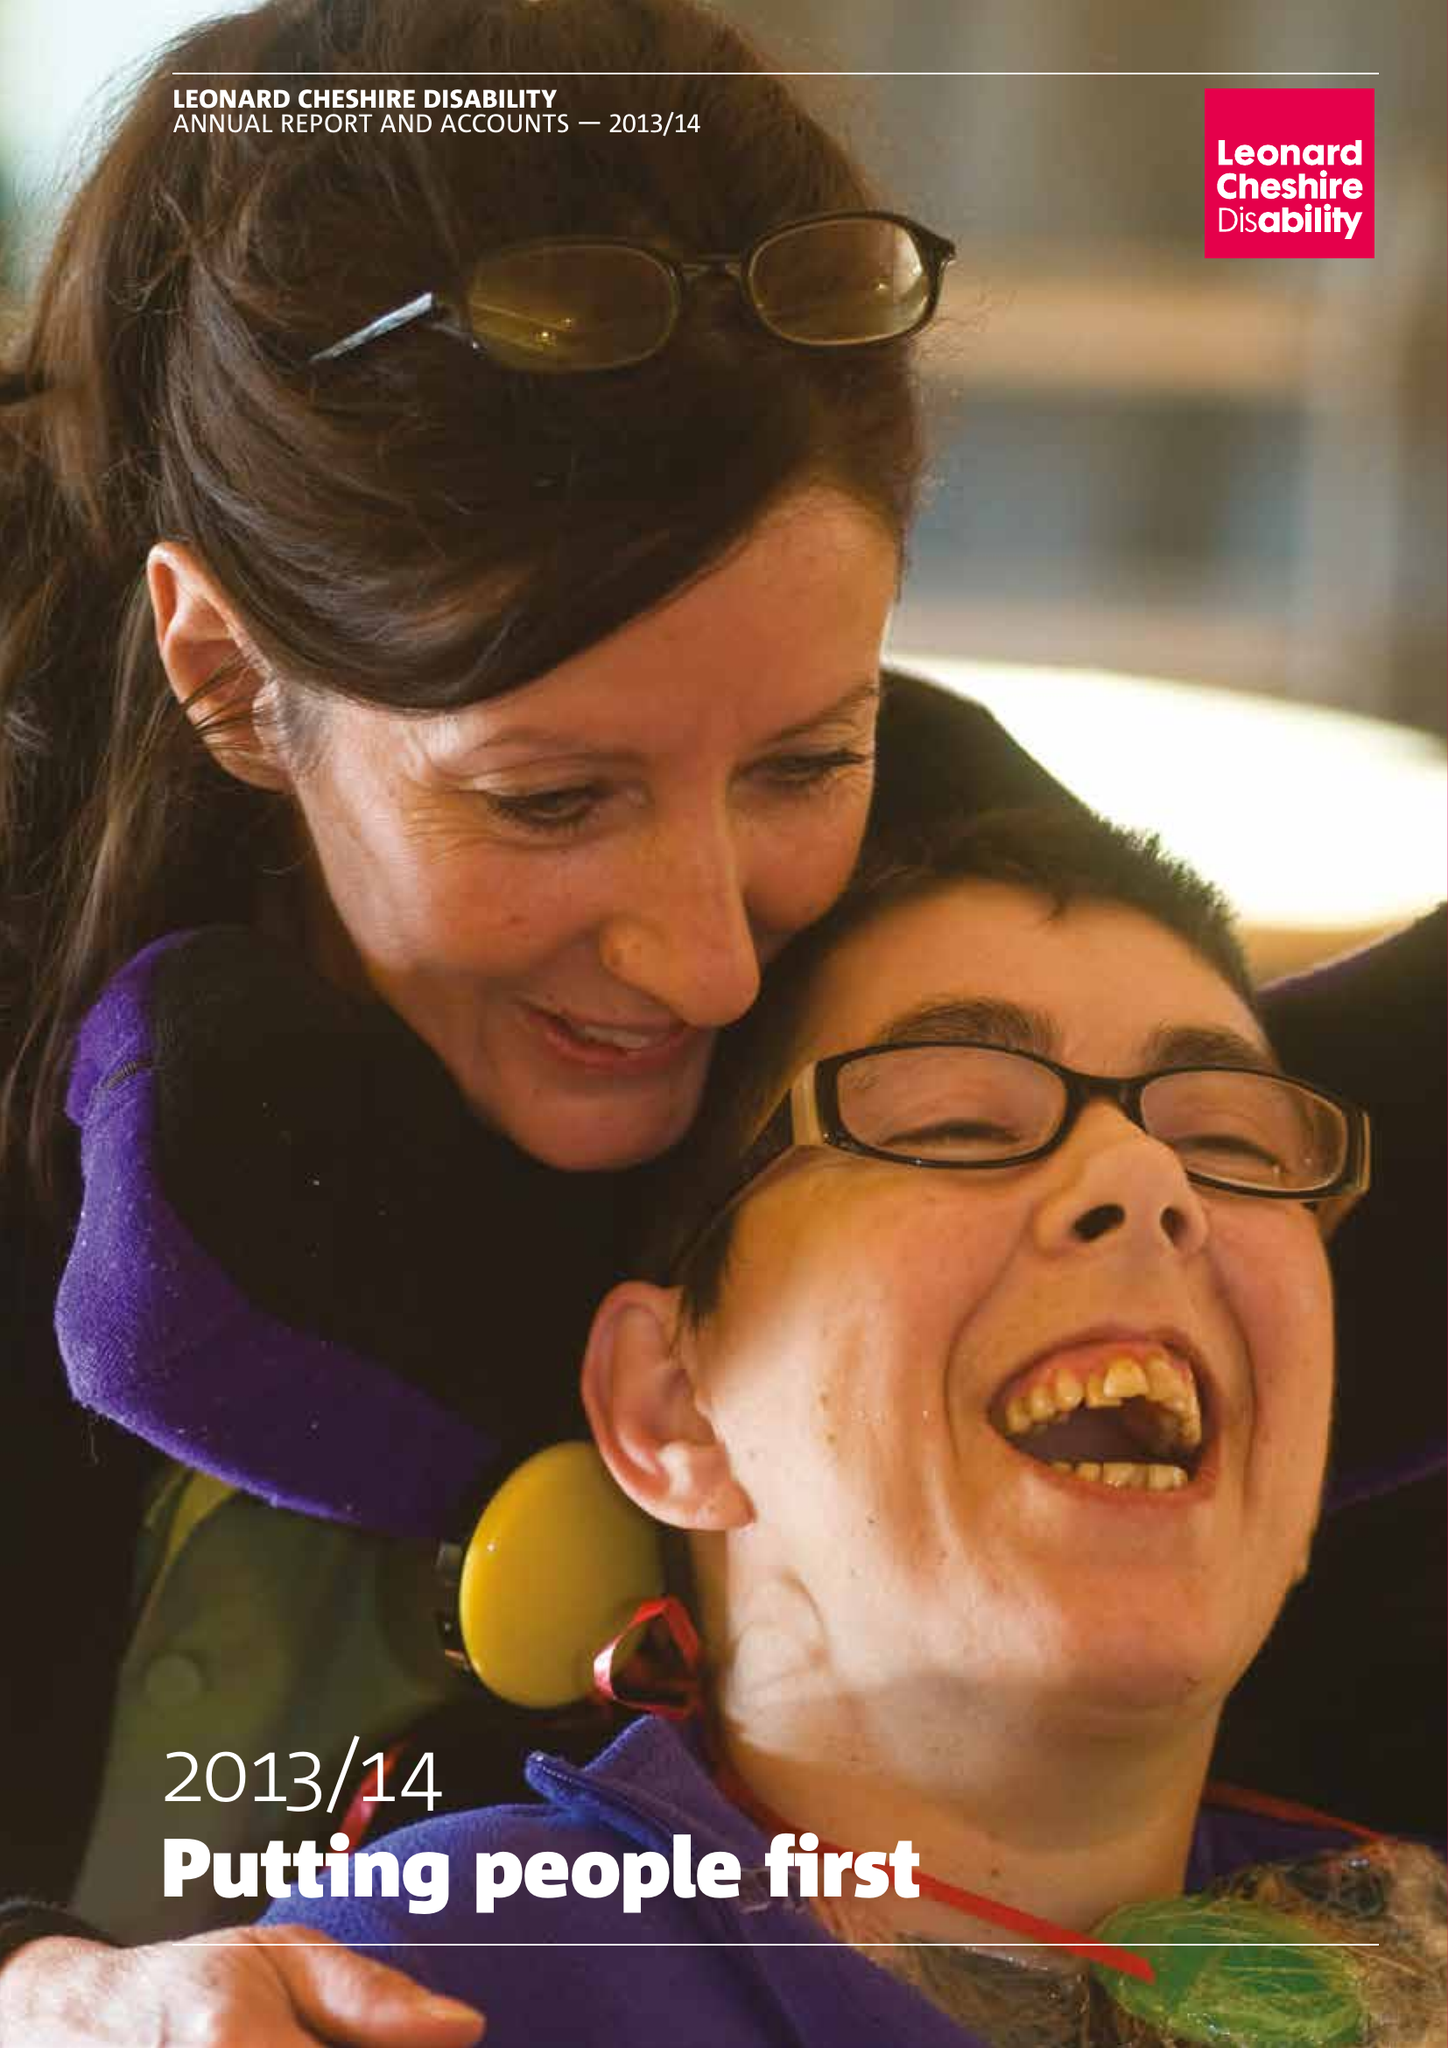What is the value for the address__post_town?
Answer the question using a single word or phrase. LONDON 